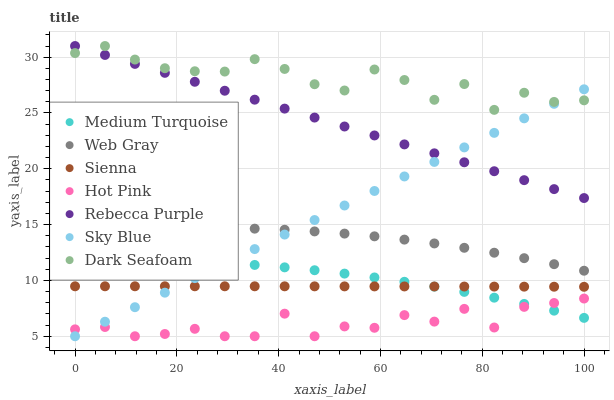Does Hot Pink have the minimum area under the curve?
Answer yes or no. Yes. Does Dark Seafoam have the maximum area under the curve?
Answer yes or no. Yes. Does Sienna have the minimum area under the curve?
Answer yes or no. No. Does Sienna have the maximum area under the curve?
Answer yes or no. No. Is Sky Blue the smoothest?
Answer yes or no. Yes. Is Dark Seafoam the roughest?
Answer yes or no. Yes. Is Hot Pink the smoothest?
Answer yes or no. No. Is Hot Pink the roughest?
Answer yes or no. No. Does Hot Pink have the lowest value?
Answer yes or no. Yes. Does Sienna have the lowest value?
Answer yes or no. No. Does Rebecca Purple have the highest value?
Answer yes or no. Yes. Does Sienna have the highest value?
Answer yes or no. No. Is Hot Pink less than Web Gray?
Answer yes or no. Yes. Is Dark Seafoam greater than Sienna?
Answer yes or no. Yes. Does Web Gray intersect Sky Blue?
Answer yes or no. Yes. Is Web Gray less than Sky Blue?
Answer yes or no. No. Is Web Gray greater than Sky Blue?
Answer yes or no. No. Does Hot Pink intersect Web Gray?
Answer yes or no. No. 